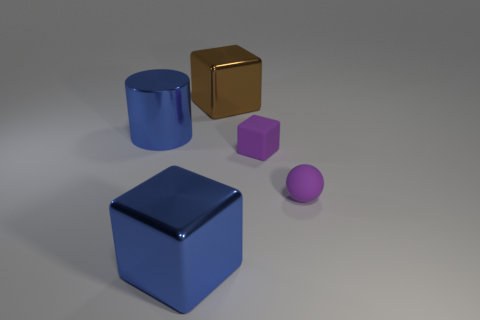Add 5 tiny purple spheres. How many objects exist? 10 Subtract all large cubes. How many cubes are left? 1 Subtract all cyan blocks. Subtract all yellow cylinders. How many blocks are left? 3 Subtract all cubes. How many objects are left? 2 Add 4 tiny yellow shiny blocks. How many tiny yellow shiny blocks exist? 4 Subtract 0 red balls. How many objects are left? 5 Subtract all purple cubes. Subtract all purple rubber blocks. How many objects are left? 3 Add 5 blue metal blocks. How many blue metal blocks are left? 6 